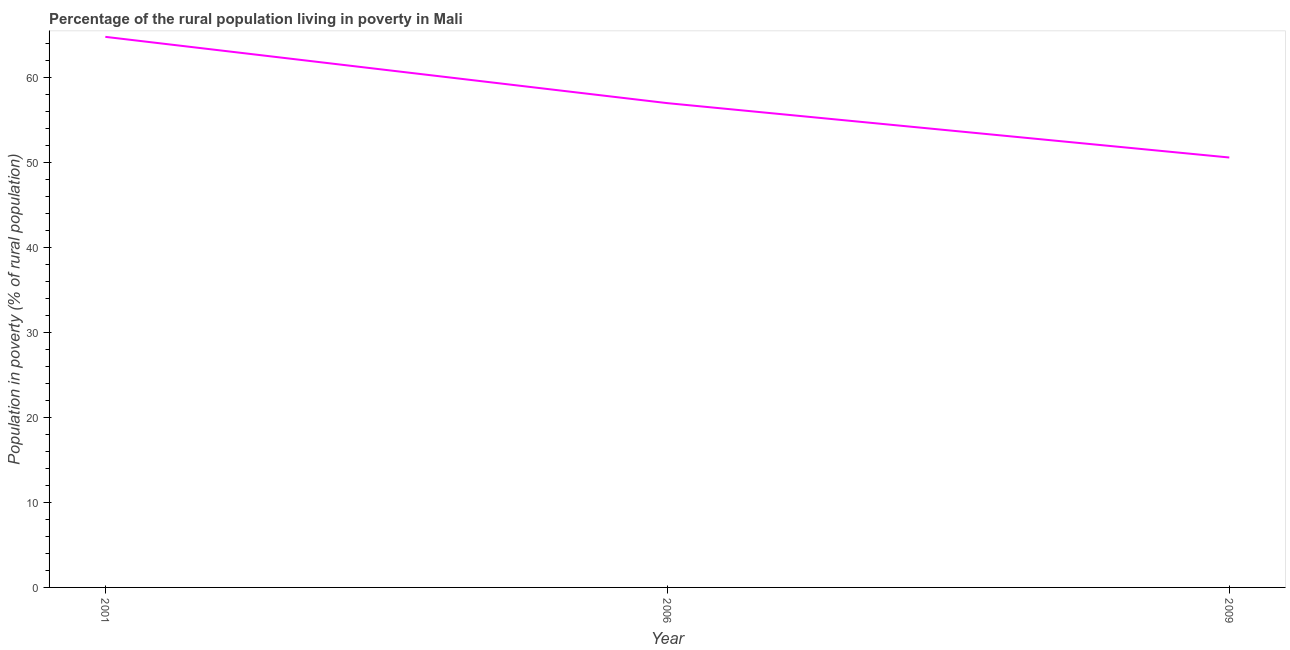What is the percentage of rural population living below poverty line in 2006?
Provide a short and direct response. 57. Across all years, what is the maximum percentage of rural population living below poverty line?
Give a very brief answer. 64.8. Across all years, what is the minimum percentage of rural population living below poverty line?
Provide a succinct answer. 50.6. What is the sum of the percentage of rural population living below poverty line?
Keep it short and to the point. 172.4. What is the difference between the percentage of rural population living below poverty line in 2001 and 2009?
Provide a succinct answer. 14.2. What is the average percentage of rural population living below poverty line per year?
Provide a succinct answer. 57.47. What is the median percentage of rural population living below poverty line?
Offer a terse response. 57. What is the ratio of the percentage of rural population living below poverty line in 2006 to that in 2009?
Provide a short and direct response. 1.13. What is the difference between the highest and the second highest percentage of rural population living below poverty line?
Give a very brief answer. 7.8. Is the sum of the percentage of rural population living below poverty line in 2006 and 2009 greater than the maximum percentage of rural population living below poverty line across all years?
Your answer should be compact. Yes. What is the difference between the highest and the lowest percentage of rural population living below poverty line?
Make the answer very short. 14.2. How many lines are there?
Your response must be concise. 1. How many years are there in the graph?
Provide a succinct answer. 3. Are the values on the major ticks of Y-axis written in scientific E-notation?
Provide a succinct answer. No. Does the graph contain any zero values?
Provide a succinct answer. No. What is the title of the graph?
Your response must be concise. Percentage of the rural population living in poverty in Mali. What is the label or title of the X-axis?
Give a very brief answer. Year. What is the label or title of the Y-axis?
Offer a terse response. Population in poverty (% of rural population). What is the Population in poverty (% of rural population) in 2001?
Ensure brevity in your answer.  64.8. What is the Population in poverty (% of rural population) of 2009?
Make the answer very short. 50.6. What is the difference between the Population in poverty (% of rural population) in 2006 and 2009?
Provide a short and direct response. 6.4. What is the ratio of the Population in poverty (% of rural population) in 2001 to that in 2006?
Your answer should be very brief. 1.14. What is the ratio of the Population in poverty (% of rural population) in 2001 to that in 2009?
Keep it short and to the point. 1.28. What is the ratio of the Population in poverty (% of rural population) in 2006 to that in 2009?
Provide a short and direct response. 1.13. 